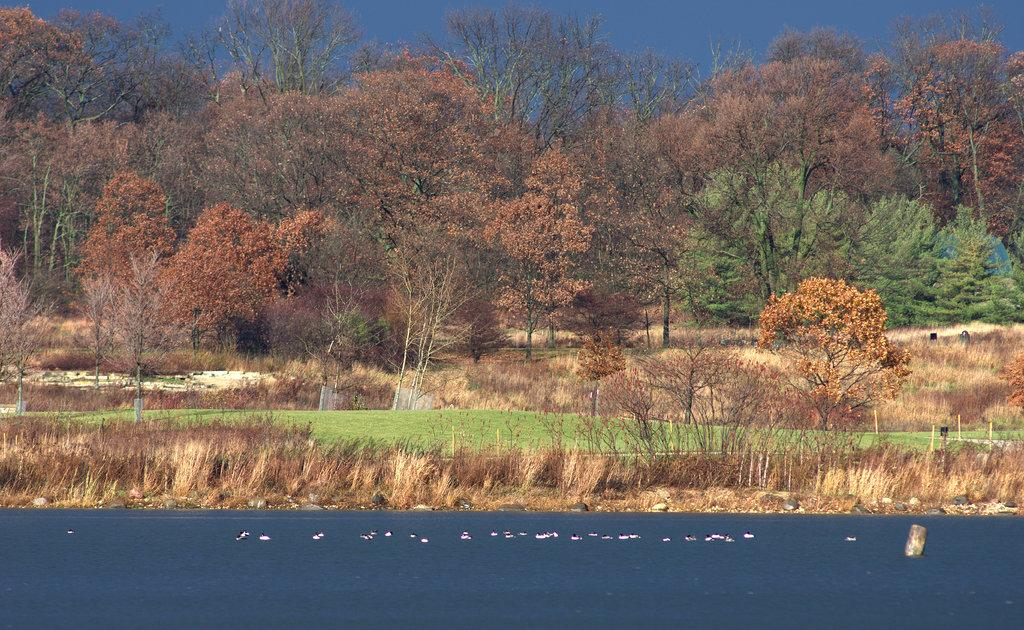What type of vegetation can be seen in the image? There are trees in the image. What natural element is visible in the image besides the trees? There is water visible in the image. What color is the sky in the image? The sky is blue in the image. What type of poison can be seen in the image? There is no poison present in the image; it features trees, water, and a blue sky. What hobbies do the trees in the image enjoy? Trees do not have hobbies, as they are inanimate objects. 